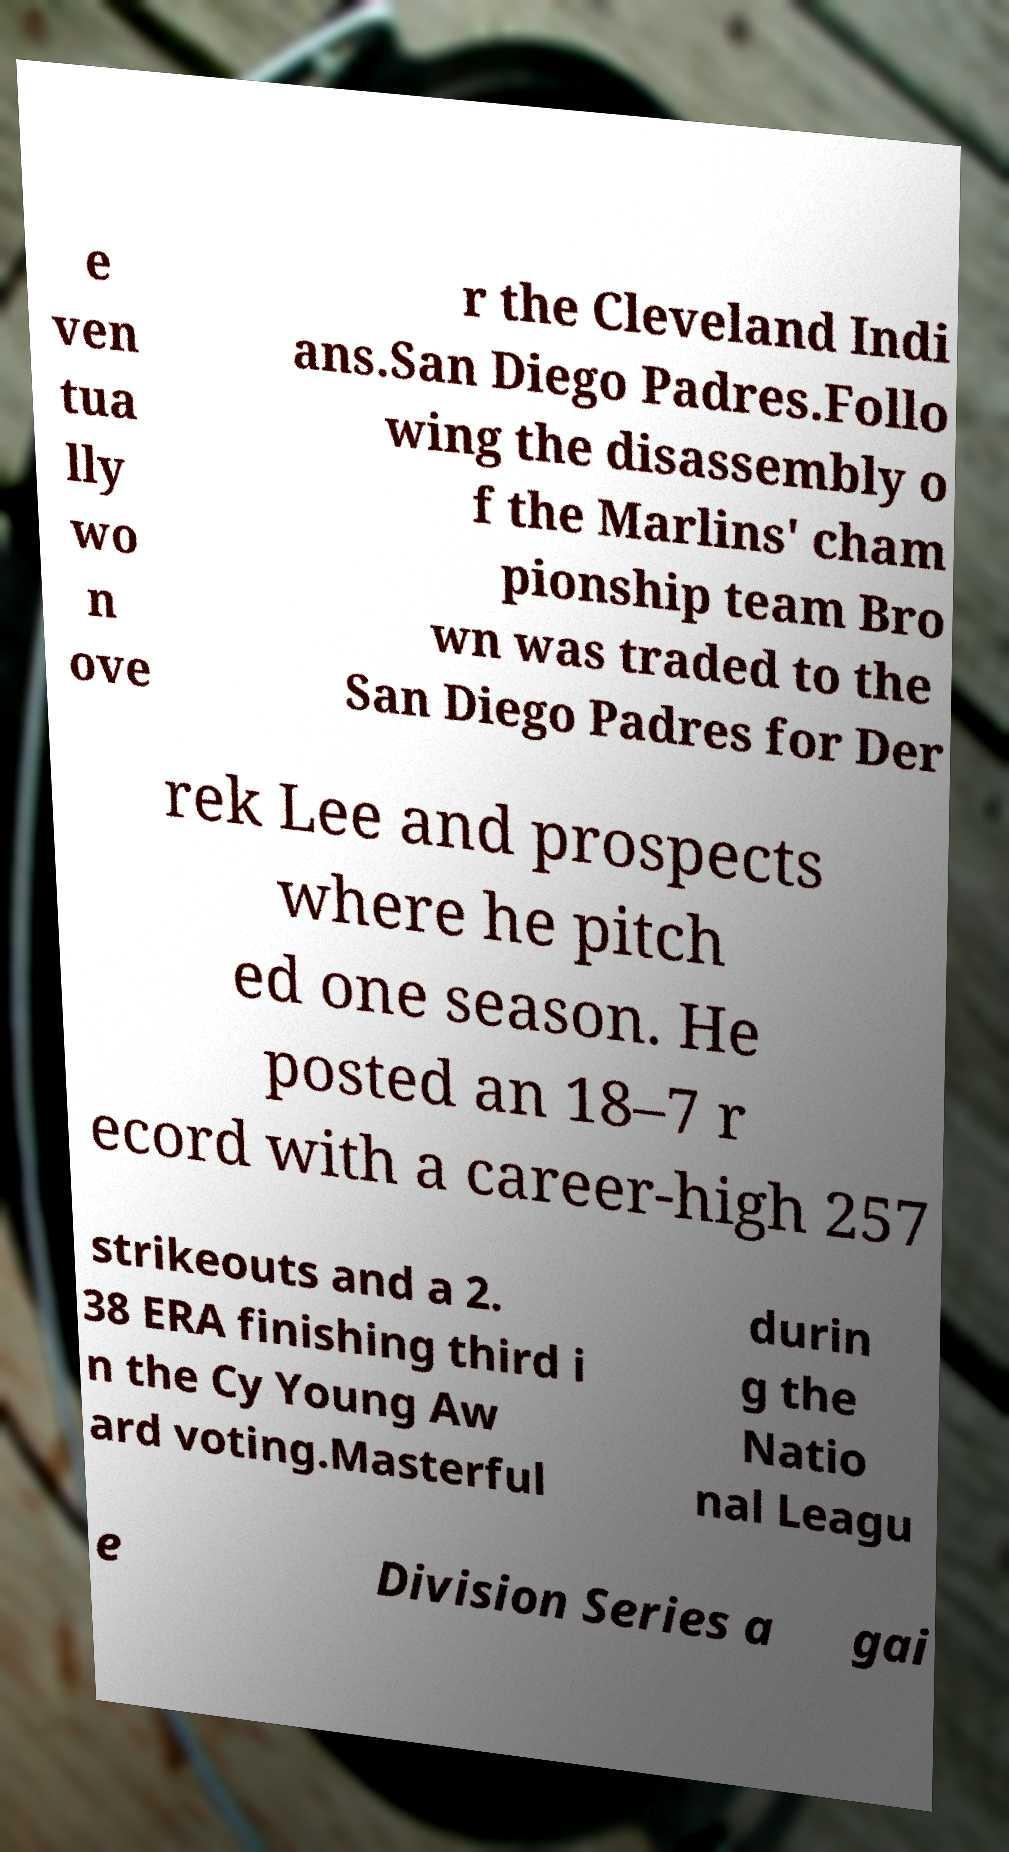Could you extract and type out the text from this image? e ven tua lly wo n ove r the Cleveland Indi ans.San Diego Padres.Follo wing the disassembly o f the Marlins' cham pionship team Bro wn was traded to the San Diego Padres for Der rek Lee and prospects where he pitch ed one season. He posted an 18–7 r ecord with a career-high 257 strikeouts and a 2. 38 ERA finishing third i n the Cy Young Aw ard voting.Masterful durin g the Natio nal Leagu e Division Series a gai 